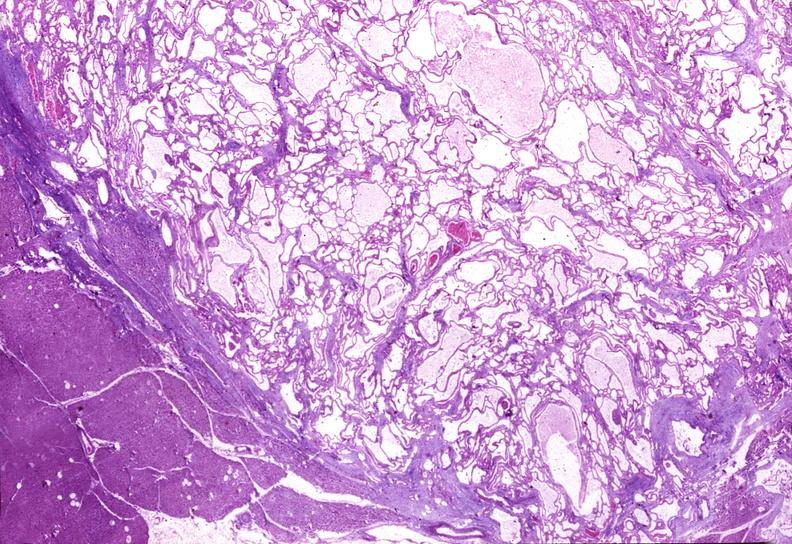does female reproductive show cystadenoma?
Answer the question using a single word or phrase. No 